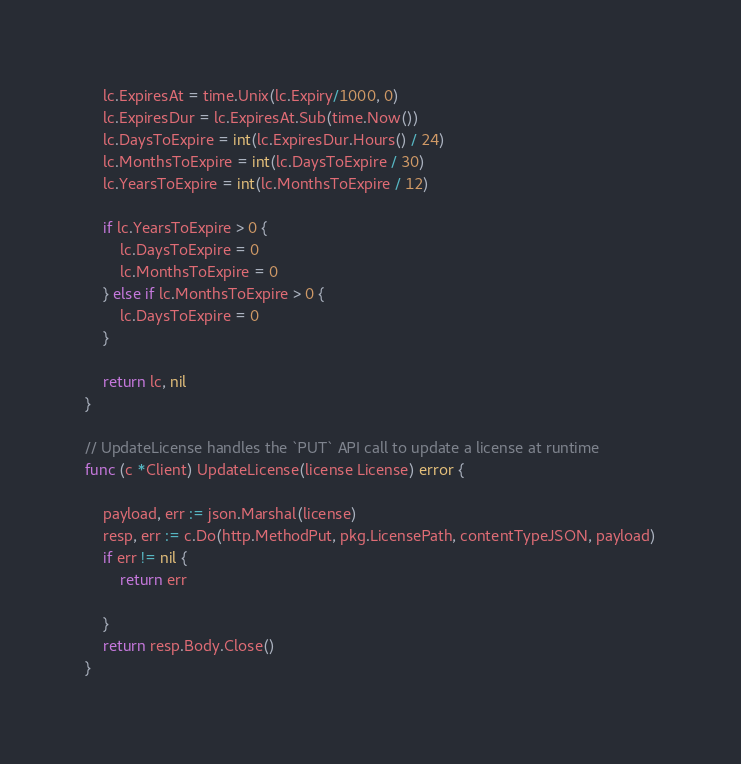<code> <loc_0><loc_0><loc_500><loc_500><_Go_>	lc.ExpiresAt = time.Unix(lc.Expiry/1000, 0)
	lc.ExpiresDur = lc.ExpiresAt.Sub(time.Now())
	lc.DaysToExpire = int(lc.ExpiresDur.Hours() / 24)
	lc.MonthsToExpire = int(lc.DaysToExpire / 30)
	lc.YearsToExpire = int(lc.MonthsToExpire / 12)

	if lc.YearsToExpire > 0 {
		lc.DaysToExpire = 0
		lc.MonthsToExpire = 0
	} else if lc.MonthsToExpire > 0 {
		lc.DaysToExpire = 0
	}

	return lc, nil
}

// UpdateLicense handles the `PUT` API call to update a license at runtime
func (c *Client) UpdateLicense(license License) error {

	payload, err := json.Marshal(license)
	resp, err := c.Do(http.MethodPut, pkg.LicensePath, contentTypeJSON, payload)
	if err != nil {
		return err

	}
	return resp.Body.Close()
}
</code> 